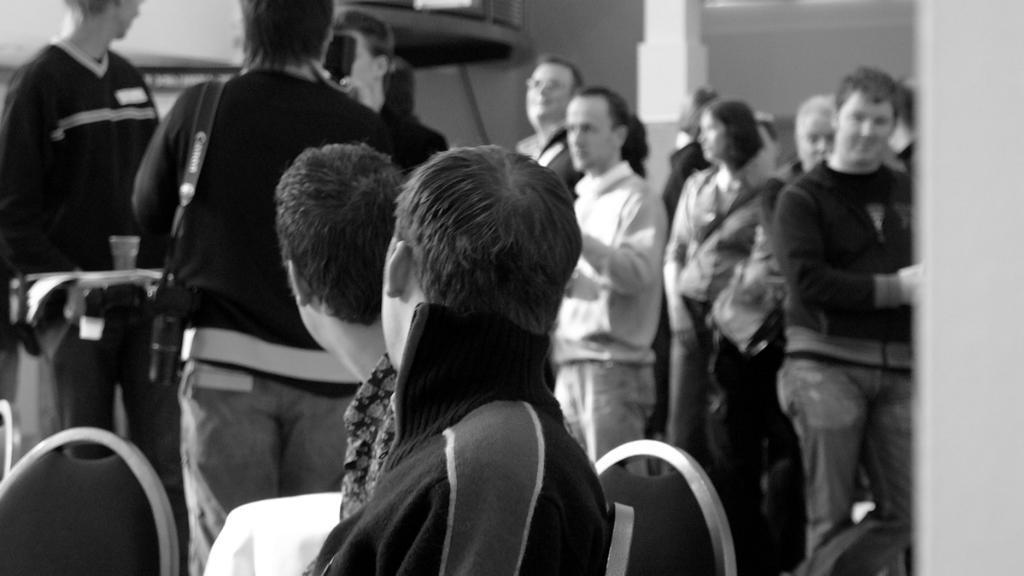Can you describe this image briefly? In this image I can see the group of people. I can see few people are sitting on the chairs and few people are standing. There is a person wearing the camera. And this is a black and white image. 